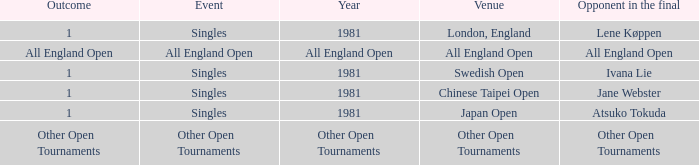What is the Outcome when All England Open is the Opponent in the final? All England Open. 